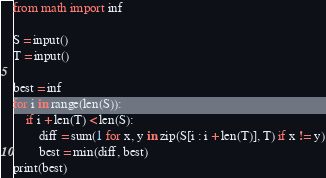<code> <loc_0><loc_0><loc_500><loc_500><_Python_>from math import inf

S = input()
T = input()

best = inf
for i in range(len(S)):
    if i + len(T) < len(S):
        diff = sum(1 for x, y in zip(S[i : i + len(T)], T) if x != y)
        best = min(diff, best)
print(best)
</code> 